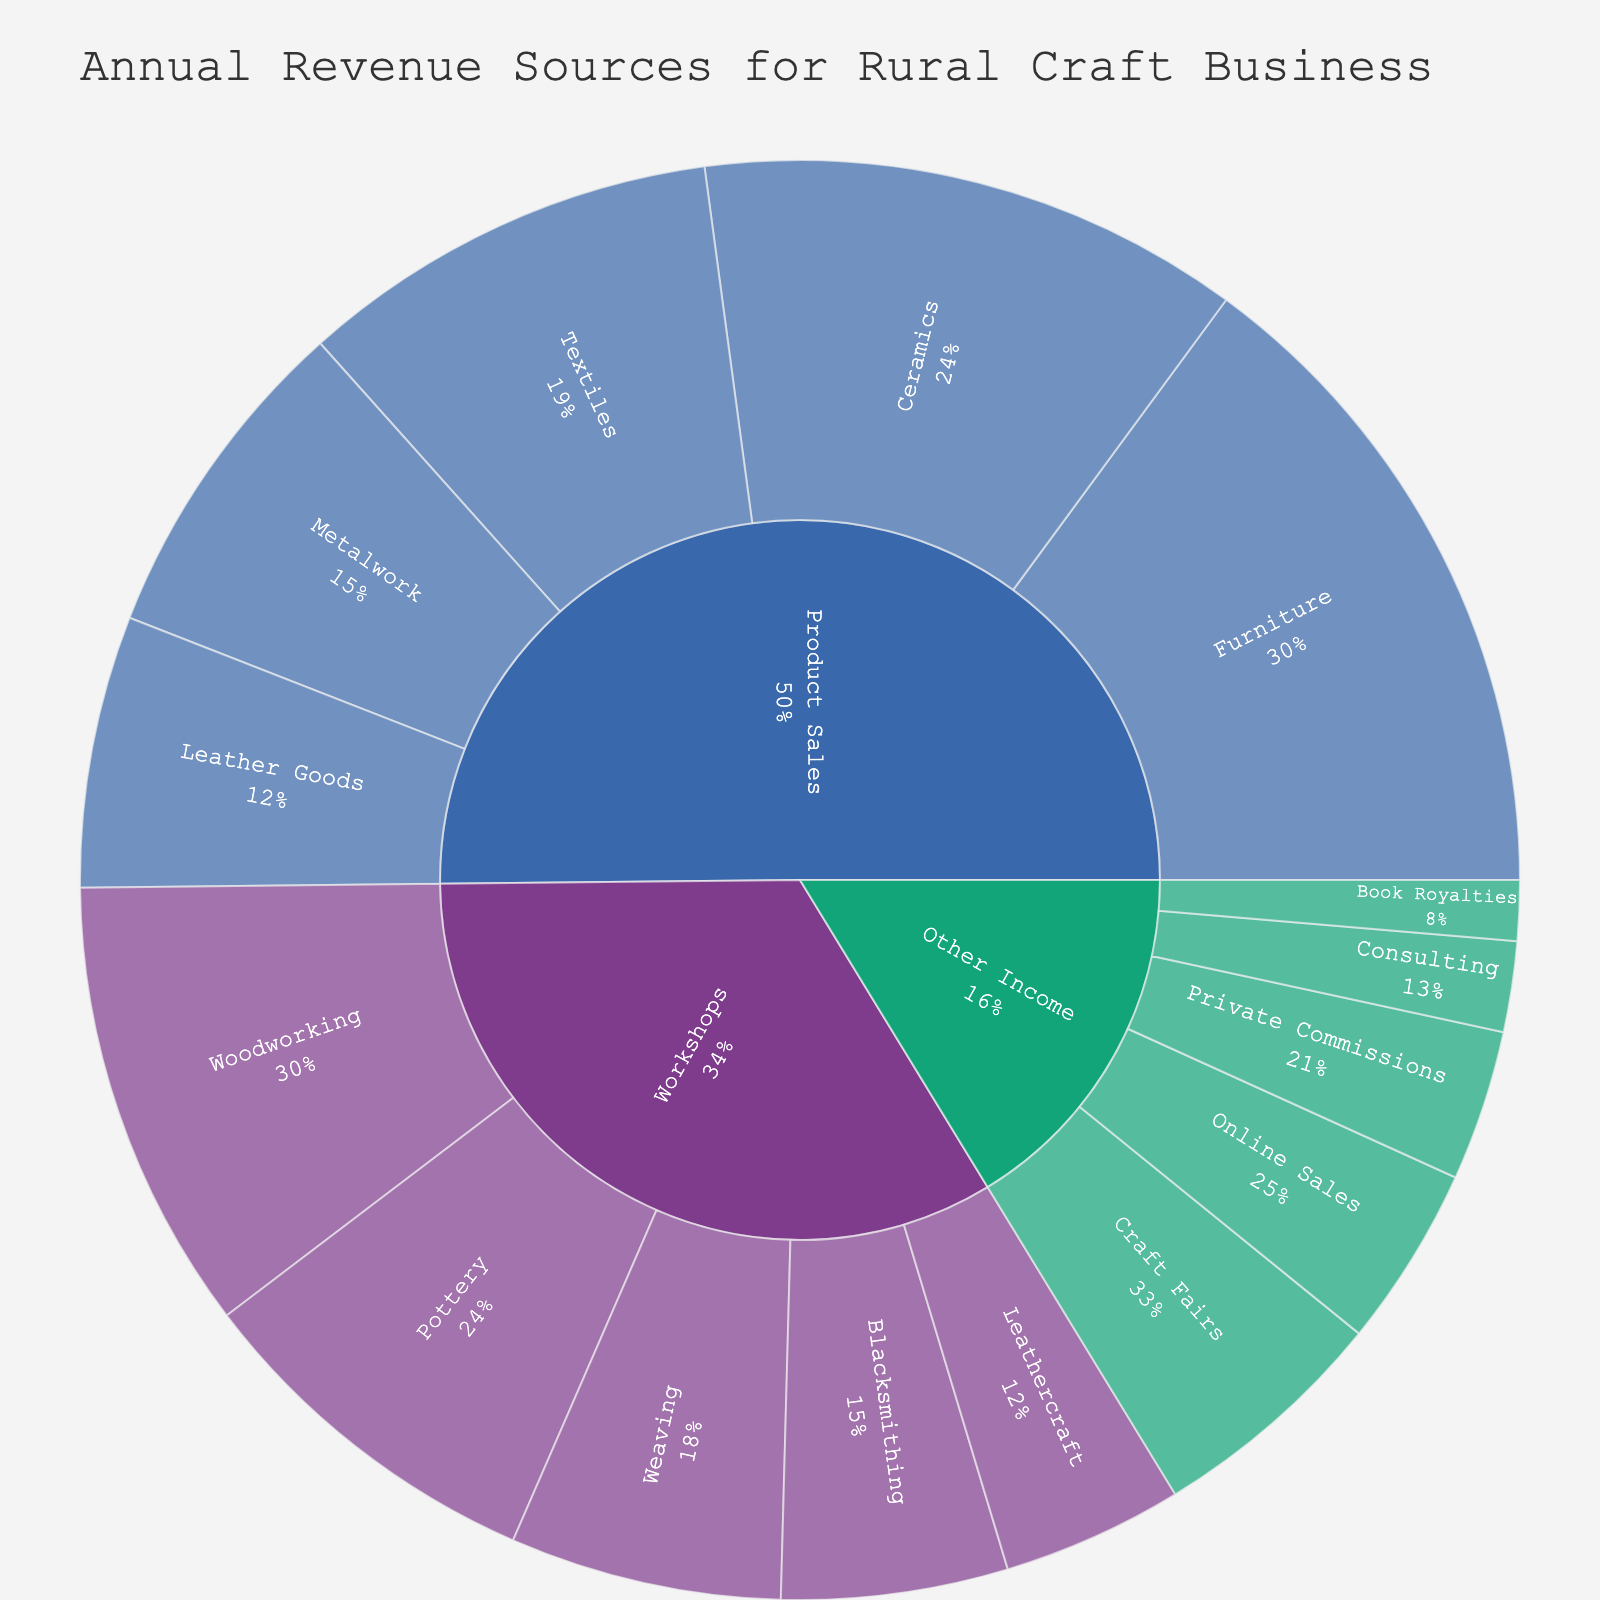What is the title of the figure? The title of the figure can be identified at the top of the visual.
Answer: Annual Revenue Sources for Rural Craft Business Which category has the highest revenue? Look at the largest segment in the outermost ring of the sunburst plot.
Answer: Product Sales What percentage of the Workshops category revenue comes from Woodworking? Find the segment for Woodworking under Workshops and read the percentage value.
Answer: 25% What is the combined revenue from Pottery and Weaving workshops? Sum the revenue values for Pottery and Weaving from the provided data: $12,000 (Pottery) + $9,000 (Weaving).
Answer: $21,000 Is the revenue from Product Sales of Furniture greater than the total revenue from Workshops? Compare the revenue from Furniture ($22,000) with the total revenue from Workshops, which is the sum of all its subcategories: $15,000 (Woodworking) + $12,000 (Pottery) + $9,000 (Weaving) + $7,500 (Blacksmithing) + $6,000 (Leathercraft) = $49,500. Since $22,000 is less than $49,500, the answer is no.
Answer: No Which subcategory under Other Income has the lowest revenue? Identify the smallest segment under Other Income in the sunburst plot.
Answer: Book Royalties Rank the subcategories under Product Sales by their revenue from highest to lowest. List the subcategories under Product Sales and their respective revenue values, then arrange in descending order: Furniture ($22,000), Ceramics ($18,000), Textiles ($14,000), Metalwork ($11,000), Leather Goods ($9,000).
Answer: Furniture, Ceramics, Textiles, Metalwork, Leather Goods What is the difference in revenue between Furniture and Ceramics product sales? Subtract the revenue of Ceramics from Furniture: $22,000 (Furniture) - $18,000 (Ceramics).
Answer: $4,000 Which category has the most diverse income sources in terms of the number of subcategories? Count the number of subcategories under each main category: Workshops (5), Product Sales (5), Other Income (5).
Answer: Workshops, Product Sales, Other Income How much higher is the revenue from Craft Fairs compared to Consulting in Other Income? Subtract the revenue of Consulting from Craft Fairs: $8,000 (Craft Fairs) - $3,000 (Consulting).
Answer: $5,000 